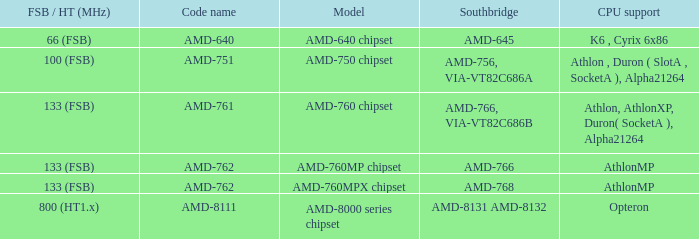Could you help me parse every detail presented in this table? {'header': ['FSB / HT (MHz)', 'Code name', 'Model', 'Southbridge', 'CPU support'], 'rows': [['66 (FSB)', 'AMD-640', 'AMD-640 chipset', 'AMD-645', 'K6 , Cyrix 6x86'], ['100 (FSB)', 'AMD-751', 'AMD-750 chipset', 'AMD-756, VIA-VT82C686A', 'Athlon , Duron ( SlotA , SocketA ), Alpha21264'], ['133 (FSB)', 'AMD-761', 'AMD-760 chipset', 'AMD-766, VIA-VT82C686B', 'Athlon, AthlonXP, Duron( SocketA ), Alpha21264'], ['133 (FSB)', 'AMD-762', 'AMD-760MP chipset', 'AMD-766', 'AthlonMP'], ['133 (FSB)', 'AMD-762', 'AMD-760MPX chipset', 'AMD-768', 'AthlonMP'], ['800 (HT1.x)', 'AMD-8111', 'AMD-8000 series chipset', 'AMD-8131 AMD-8132', 'Opteron']]} What shows for Southbridge when the Model number is amd-640 chipset? AMD-645. 